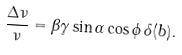Convert formula to latex. <formula><loc_0><loc_0><loc_500><loc_500>\frac { \Delta \nu } { \nu } = \beta \gamma \sin \alpha \cos \phi \, \delta ( { b } ) .</formula> 